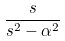Convert formula to latex. <formula><loc_0><loc_0><loc_500><loc_500>\frac { s } { s ^ { 2 } - \alpha ^ { 2 } }</formula> 